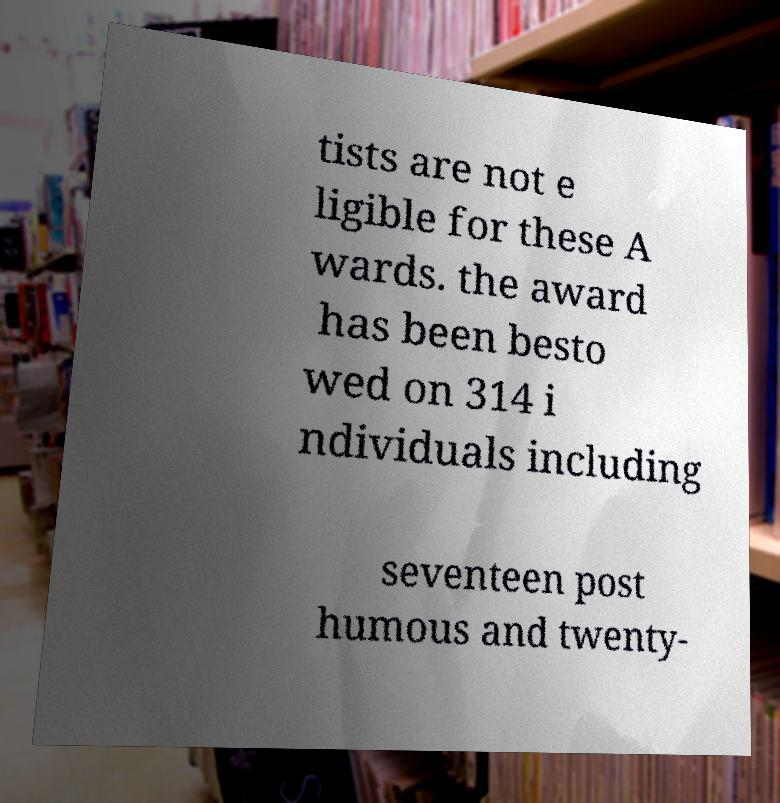For documentation purposes, I need the text within this image transcribed. Could you provide that? tists are not e ligible for these A wards. the award has been besto wed on 314 i ndividuals including seventeen post humous and twenty- 